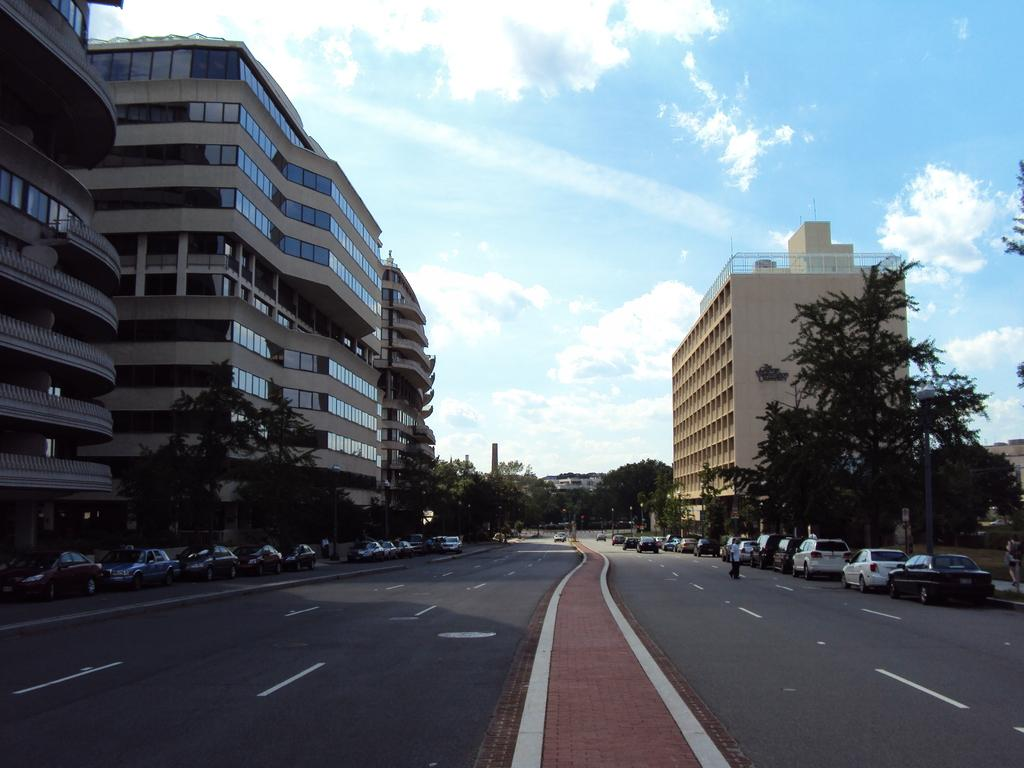What type of structures can be seen in the image? There are buildings in the image. What type of natural elements can be seen in the image? There are trees in the image. What type of vehicles can be seen in the image? There are parked cars on the road in the image. How many rings can be seen on the fingers of the maid in the image? There is no maid present in the image, and therefore no rings can be observed. 